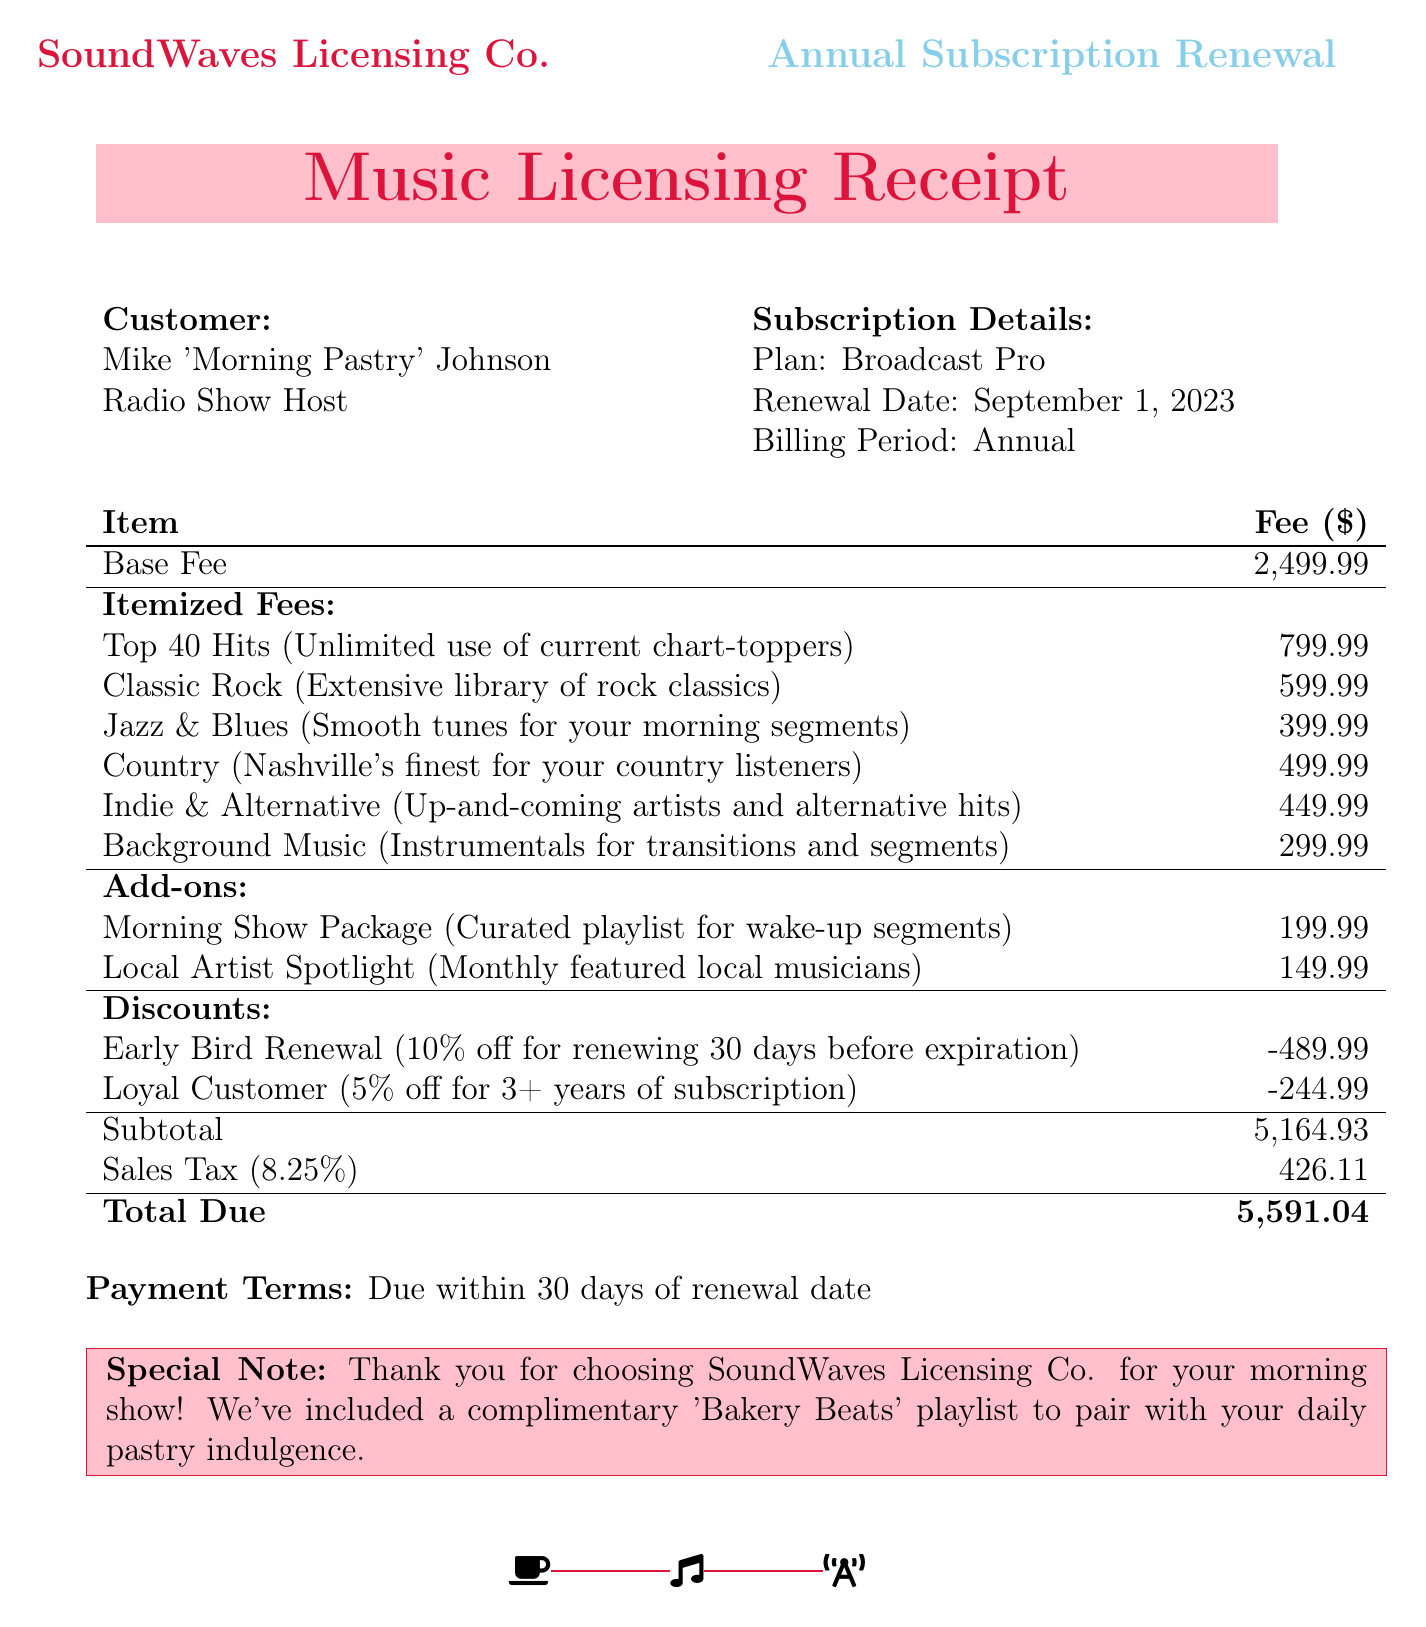What is the name of the company? The document specifies the company responsible for the subscription renewal, which is "SoundWaves Licensing Co."
Answer: SoundWaves Licensing Co Who is the customer? The document provides the name of the customer as "Mike 'Morning Pastry' Johnson."
Answer: Mike 'Morning Pastry' Johnson What is the renewal date? The renewal date is stated clearly in the document, which is "September 1, 2023."
Answer: September 1, 2023 What is the total due amount? The document indicates the total amount that needs to be paid at the bottom, which is "$5,591.04."
Answer: $5,591.04 What is the fee for the "Top 40 Hits" category? The document lists the fee specifically for the "Top 40 Hits," which is "$799.99."
Answer: $799.99 How much is the "Early Bird Renewal" discount? The amount for the "Early Bird Renewal" discount is mentioned in the document as "-$489.99."
Answer: -$489.99 What package is included as an add-on? The document details the "Morning Show Package" as one of the additional options offered.
Answer: Morning Show Package What percentage is the sales tax rate? The document states the sales tax rate explicitly, which is "8.25%."
Answer: 8.25% What is included in the special note? The special note expresses gratitude and mentions a complimentary playlist, which is "Bakery Beats."
Answer: Bakery Beats 